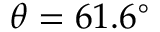<formula> <loc_0><loc_0><loc_500><loc_500>\theta = 6 1 . 6 ^ { \circ }</formula> 